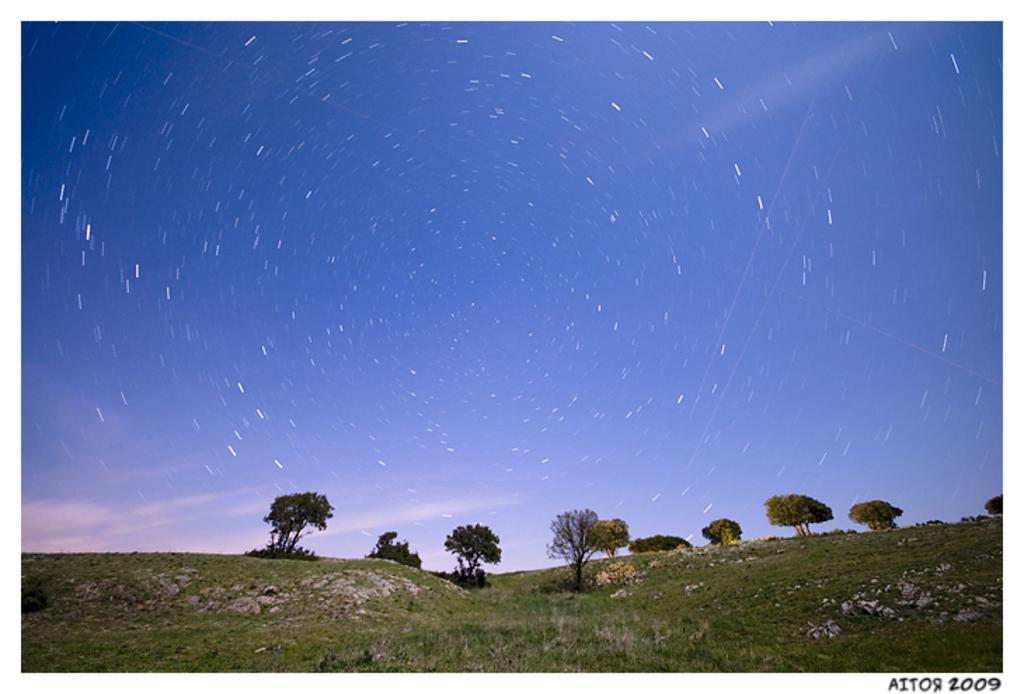Please provide a concise description of this image. In the center of the image there are trees. At the bottom there is grass. In the background there is sky. 